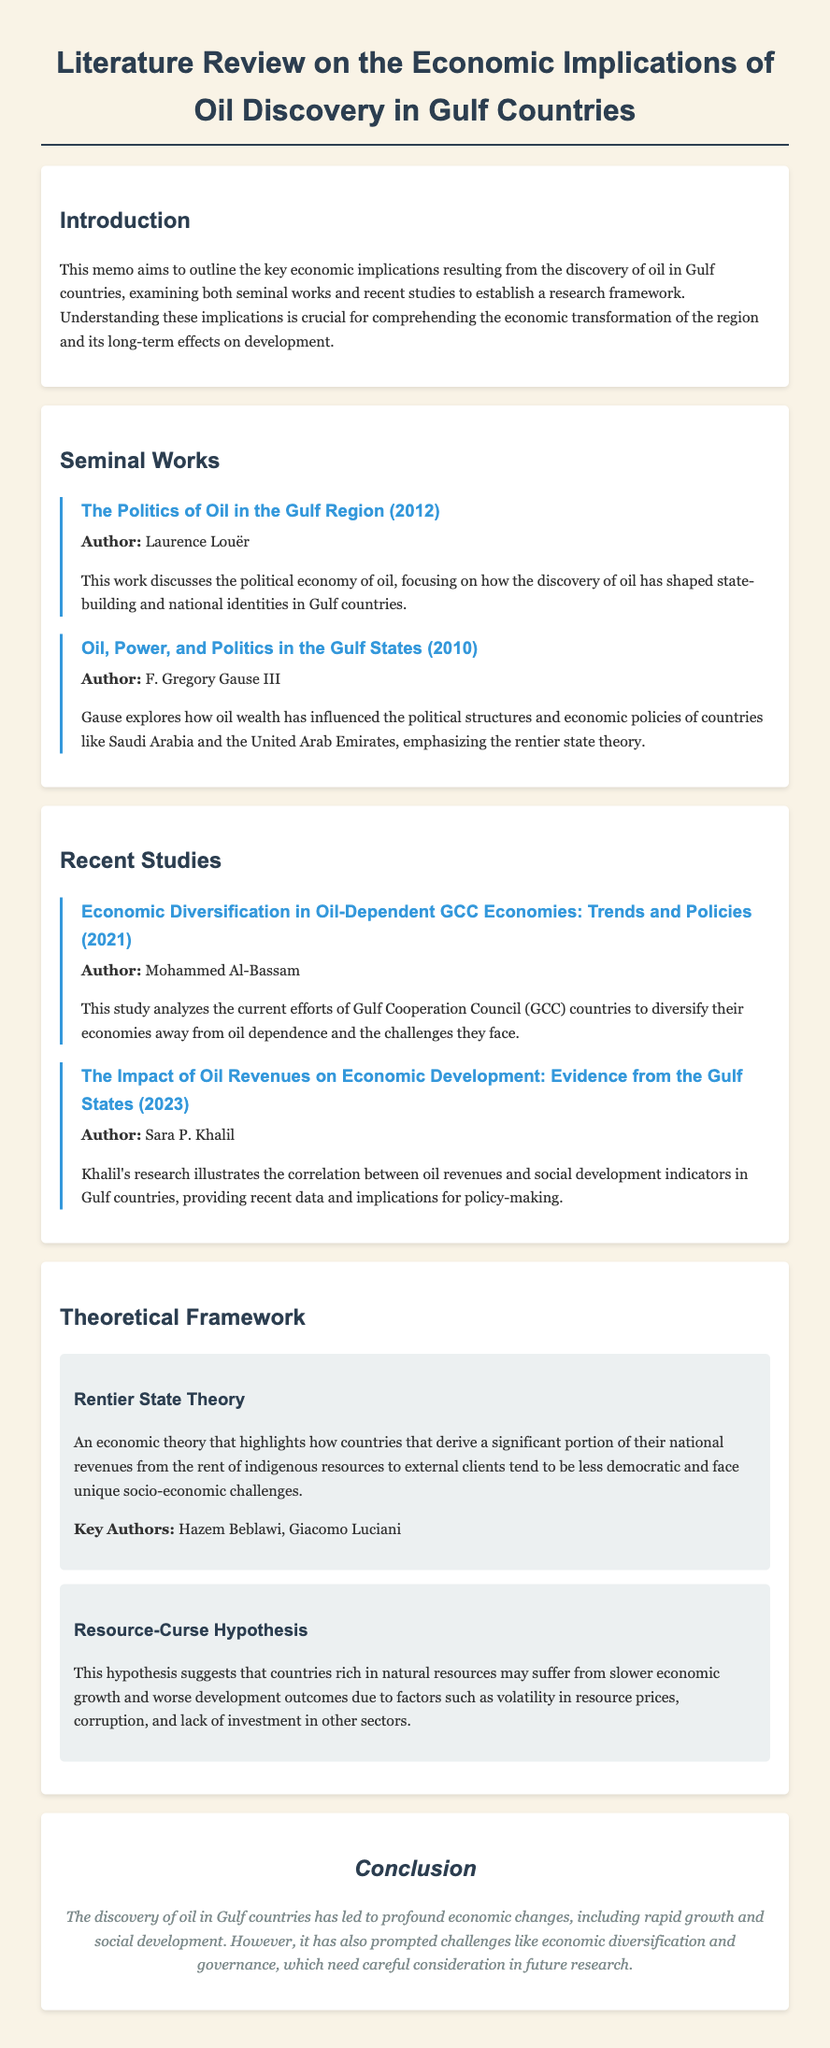What is the title of the memo? The title is presented at the top of the document, summarizing its focus.
Answer: Literature Review on the Economic Implications of Oil Discovery in Gulf Countries Who is the author of "The Politics of Oil in the Gulf Region"? The author's name is listed under each seminal work in the document.
Answer: Laurence Louër In what year was "Oil, Power, and Politics in the Gulf States" published? The publication year is noted next to the titles in the seminal works section.
Answer: 2010 What theory highlights the challenges faced by countries deriving revenue from natural resources? The theory is mentioned in the theoretical framework section and is pertinent to the discussion of resource management.
Answer: Rentier State Theory Who conducted the study on economic diversification in GCC economies? The author is specified in the recent studies section, indicating who contributed to this area of research.
Answer: Mohammed Al-Bassam What is the main focus of Sara P. Khalil's 2023 study? The focus of the study is highlighted in its description, summarizing its contribution to the understanding of oil revenues.
Answer: Correlation between oil revenues and social development indicators What hypothesis suggests that resource-rich countries may face worse development outcomes? The hypothesis is listed in the theoretical framework and underlines important socio-economic issues.
Answer: Resource-Curse Hypothesis What is the key economic challenge mentioned in the conclusion of the memo? The conclusion summarizes the major challenges faced by Gulf countries in their economic evolution.
Answer: Economic diversification 